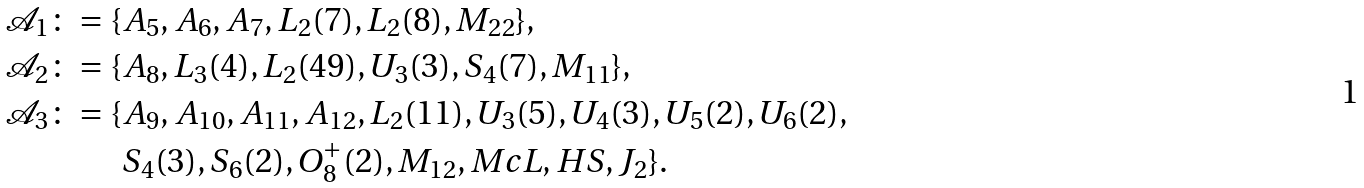<formula> <loc_0><loc_0><loc_500><loc_500>\mathcal { A } _ { 1 } \colon = \{ & A _ { 5 } , A _ { 6 } , A _ { 7 } , L _ { 2 } ( 7 ) , L _ { 2 } ( 8 ) , M _ { 2 2 } \} , \\ \mathcal { A } _ { 2 } \colon = \{ & A _ { 8 } , L _ { 3 } ( 4 ) , L _ { 2 } ( 4 9 ) , U _ { 3 } ( 3 ) , S _ { 4 } ( 7 ) , M _ { 1 1 } \} , \\ \mathcal { A } _ { 3 } \colon = \{ & A _ { 9 } , A _ { 1 0 } , A _ { 1 1 } , A _ { 1 2 } , L _ { 2 } ( 1 1 ) , U _ { 3 } ( 5 ) , U _ { 4 } ( 3 ) , U _ { 5 } ( 2 ) , U _ { 6 } ( 2 ) , \\ & S _ { 4 } ( 3 ) , S _ { 6 } ( 2 ) , O _ { 8 } ^ { + } ( 2 ) , M _ { 1 2 } , M c L , H S , J _ { 2 } \} .</formula> 